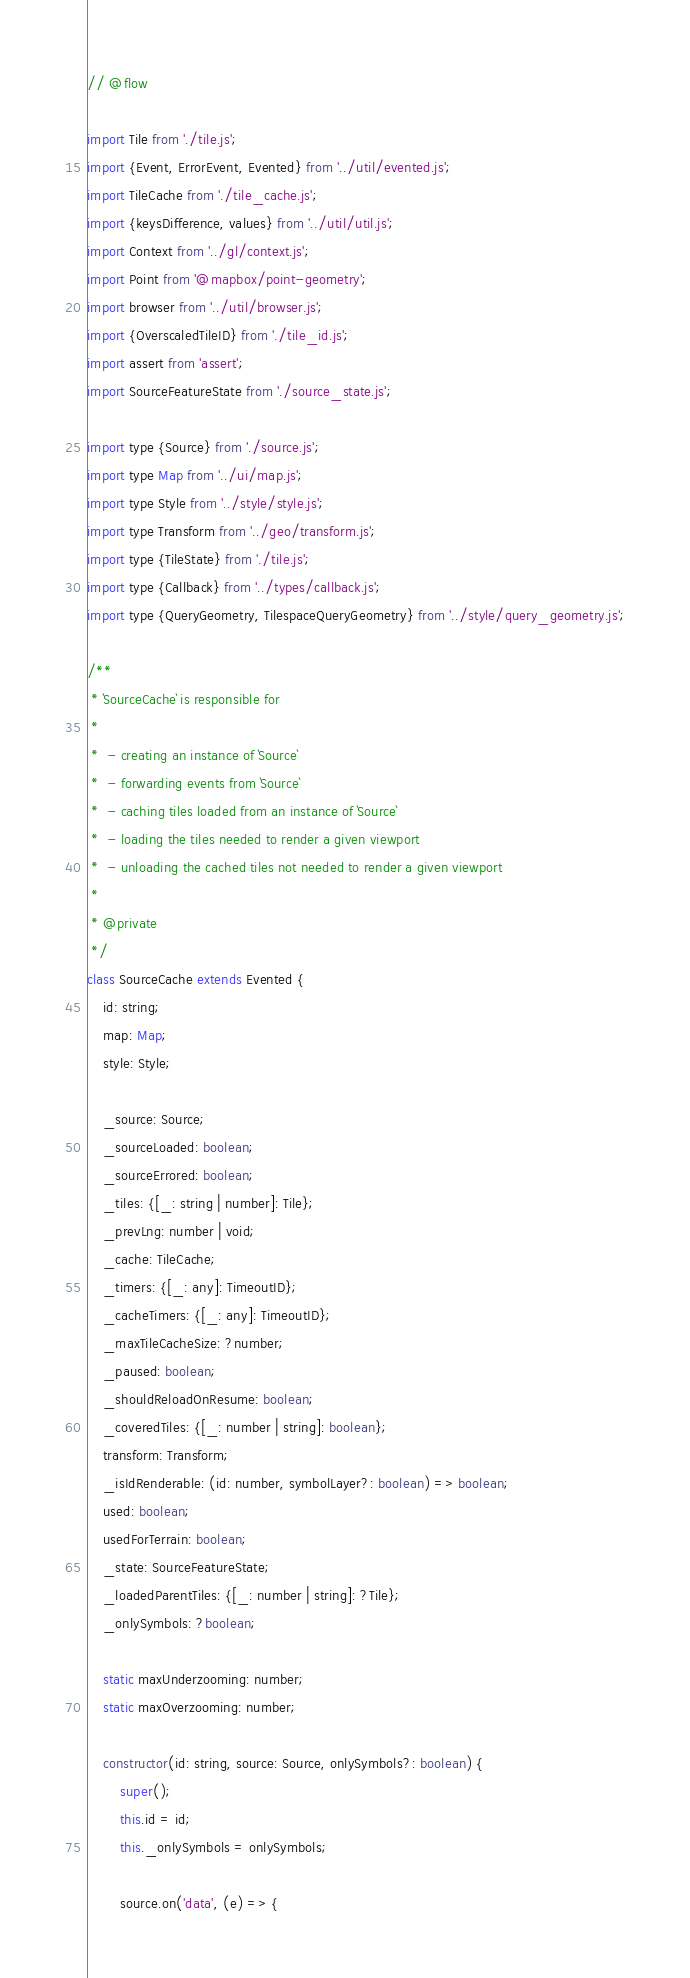Convert code to text. <code><loc_0><loc_0><loc_500><loc_500><_JavaScript_>// @flow

import Tile from './tile.js';
import {Event, ErrorEvent, Evented} from '../util/evented.js';
import TileCache from './tile_cache.js';
import {keysDifference, values} from '../util/util.js';
import Context from '../gl/context.js';
import Point from '@mapbox/point-geometry';
import browser from '../util/browser.js';
import {OverscaledTileID} from './tile_id.js';
import assert from 'assert';
import SourceFeatureState from './source_state.js';

import type {Source} from './source.js';
import type Map from '../ui/map.js';
import type Style from '../style/style.js';
import type Transform from '../geo/transform.js';
import type {TileState} from './tile.js';
import type {Callback} from '../types/callback.js';
import type {QueryGeometry, TilespaceQueryGeometry} from '../style/query_geometry.js';

/**
 * `SourceCache` is responsible for
 *
 *  - creating an instance of `Source`
 *  - forwarding events from `Source`
 *  - caching tiles loaded from an instance of `Source`
 *  - loading the tiles needed to render a given viewport
 *  - unloading the cached tiles not needed to render a given viewport
 *
 * @private
 */
class SourceCache extends Evented {
    id: string;
    map: Map;
    style: Style;

    _source: Source;
    _sourceLoaded: boolean;
    _sourceErrored: boolean;
    _tiles: {[_: string | number]: Tile};
    _prevLng: number | void;
    _cache: TileCache;
    _timers: {[_: any]: TimeoutID};
    _cacheTimers: {[_: any]: TimeoutID};
    _maxTileCacheSize: ?number;
    _paused: boolean;
    _shouldReloadOnResume: boolean;
    _coveredTiles: {[_: number | string]: boolean};
    transform: Transform;
    _isIdRenderable: (id: number, symbolLayer?: boolean) => boolean;
    used: boolean;
    usedForTerrain: boolean;
    _state: SourceFeatureState;
    _loadedParentTiles: {[_: number | string]: ?Tile};
    _onlySymbols: ?boolean;

    static maxUnderzooming: number;
    static maxOverzooming: number;

    constructor(id: string, source: Source, onlySymbols?: boolean) {
        super();
        this.id = id;
        this._onlySymbols = onlySymbols;

        source.on('data', (e) => {</code> 